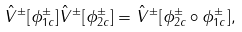<formula> <loc_0><loc_0><loc_500><loc_500>\hat { V } ^ { \pm } [ \phi _ { 1 c } ^ { \pm } ] \hat { V } ^ { \pm } [ \phi _ { 2 c } ^ { \pm } ] = \hat { V } ^ { \pm } [ \phi _ { 2 c } ^ { \pm } \circ \phi _ { 1 c } ^ { \pm } ] ,</formula> 